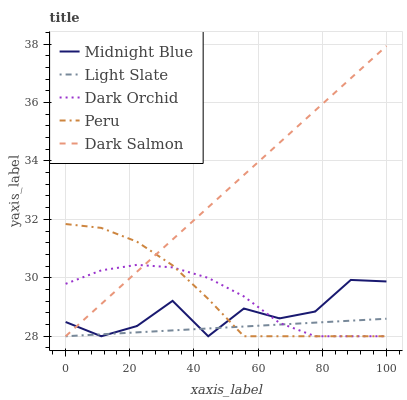Does Light Slate have the minimum area under the curve?
Answer yes or no. Yes. Does Dark Salmon have the maximum area under the curve?
Answer yes or no. Yes. Does Peru have the minimum area under the curve?
Answer yes or no. No. Does Peru have the maximum area under the curve?
Answer yes or no. No. Is Dark Salmon the smoothest?
Answer yes or no. Yes. Is Midnight Blue the roughest?
Answer yes or no. Yes. Is Peru the smoothest?
Answer yes or no. No. Is Peru the roughest?
Answer yes or no. No. Does Light Slate have the lowest value?
Answer yes or no. Yes. Does Dark Salmon have the highest value?
Answer yes or no. Yes. Does Peru have the highest value?
Answer yes or no. No. Does Dark Orchid intersect Dark Salmon?
Answer yes or no. Yes. Is Dark Orchid less than Dark Salmon?
Answer yes or no. No. Is Dark Orchid greater than Dark Salmon?
Answer yes or no. No. 